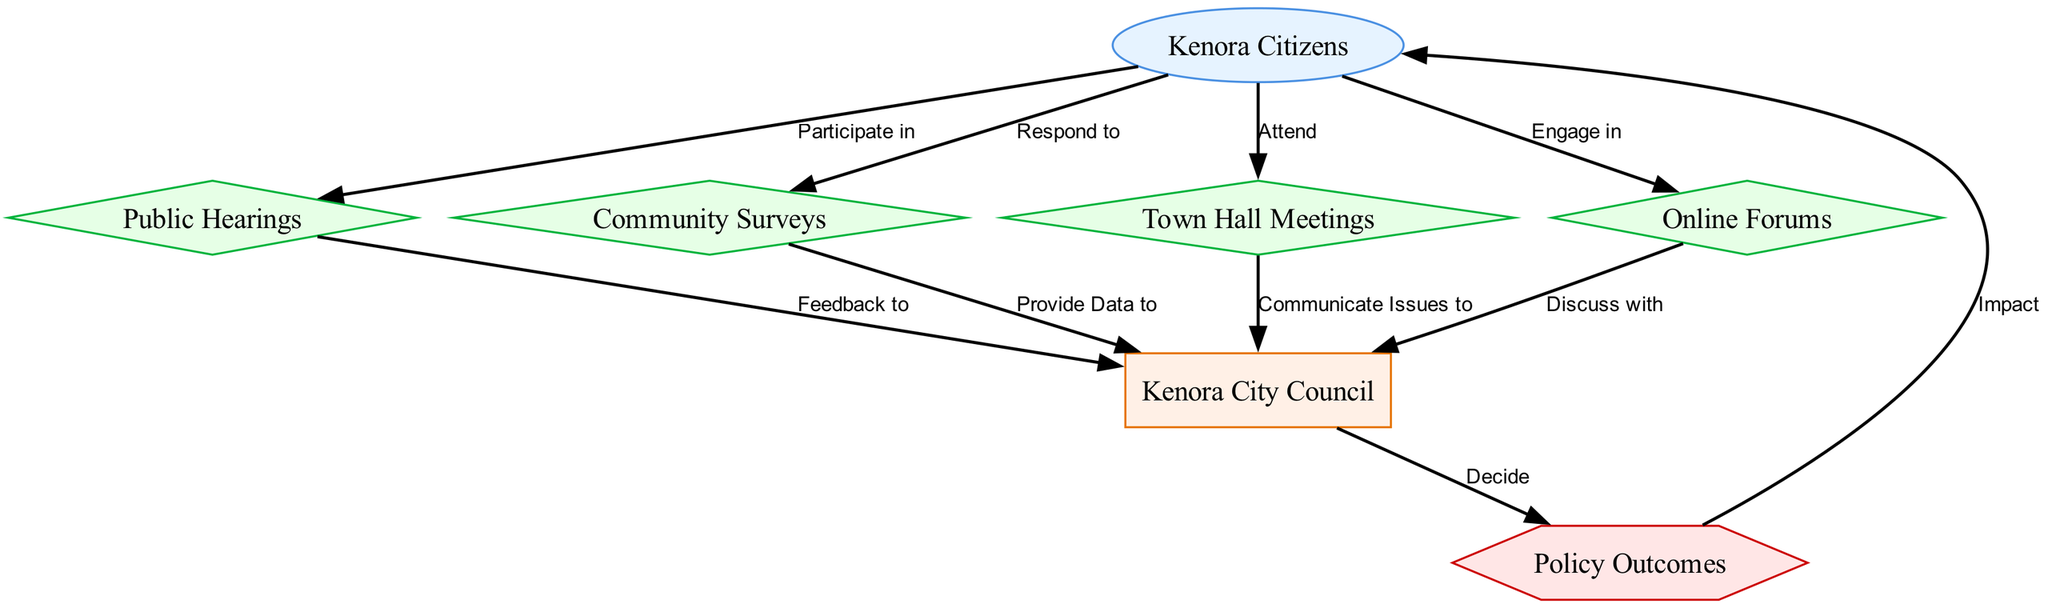What is the role of Kenora Citizens in the policy-making process? Kenora Citizens participate in public hearings, respond to surveys, attend town hall meetings, and engage in online forums. This indicates their active involvement in the channels of public participation.
Answer: Participate in public hearings, respond to surveys, attend town hall meetings, engage in online forums How many channels of participation are included in the diagram? The diagram includes four channels of participation: public hearings, community surveys, town hall meetings, and online forums. By counting these channel nodes, we find that there are a total of four.
Answer: Four What feedback mechanisms exist between citizens and the city council? Citizens provide feedback to the Kenora City Council through public hearings, represent data through surveys, communicate issues during town hall meetings, and discuss topics in online forums. This indicates multiple channels exist for this feedback.
Answer: Public hearings, surveys, town hall meetings, online forums Which node represents the result of the interactions in the diagram? The node that represents the result of the interactions among citizens and the city council is labeled as policy outcomes. By identifying the shape and label type in the diagram, we can ascertain this is the correct node for results.
Answer: Policy outcomes What does the city council decide based on citizen engagement? The city council decides on policy outcomes, which are influenced by feedback and data communicated to them through the various citizen engagement channels identified in the diagram. By examining the flow from the city council to the policy outcomes node, we see their decision impact.
Answer: Policy outcomes Which channel requires active attendance from citizens? The channel that requires active attendance from citizens is the town hall meetings, as this involves citizens attending in person to discuss issues. This can be seen from the respective edge connecting citizens to the town hall meetings node.
Answer: Town hall meetings What type of feedback do community surveys provide to the city council? Community surveys provide data to the city council, allowing them to gauge public opinion and issue priorities. The edge shown in the diagram specifies this feedback route clearly labeling it.
Answer: Provide data to 